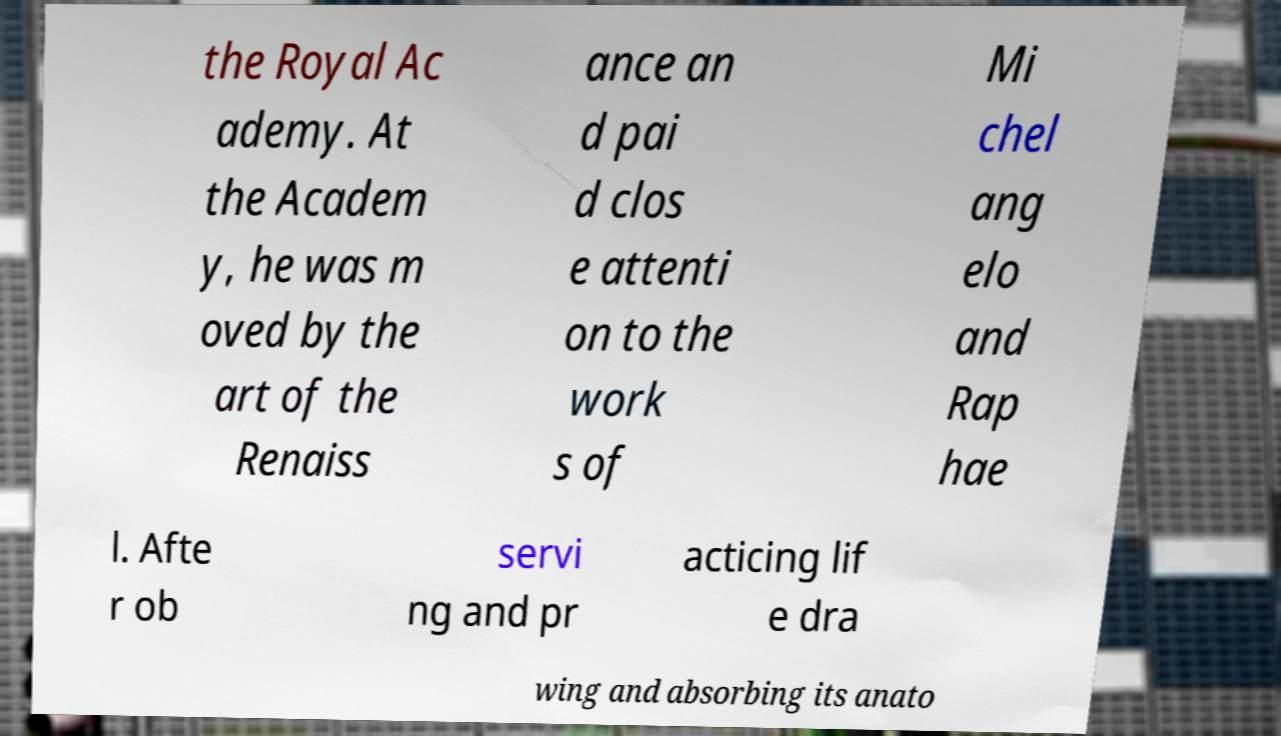I need the written content from this picture converted into text. Can you do that? the Royal Ac ademy. At the Academ y, he was m oved by the art of the Renaiss ance an d pai d clos e attenti on to the work s of Mi chel ang elo and Rap hae l. Afte r ob servi ng and pr acticing lif e dra wing and absorbing its anato 